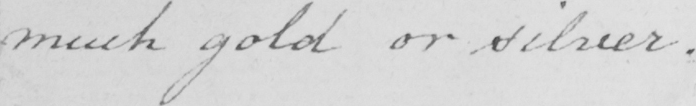What text is written in this handwritten line? much gold or silver . 